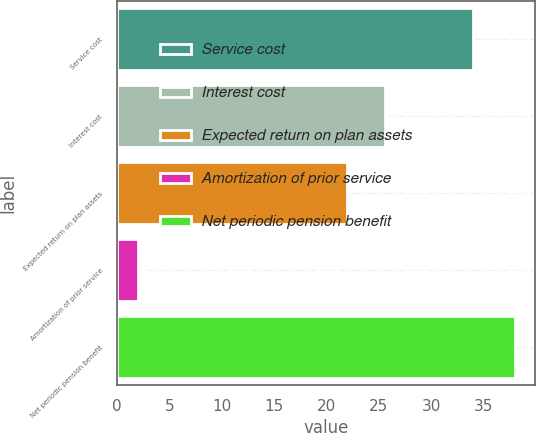<chart> <loc_0><loc_0><loc_500><loc_500><bar_chart><fcel>Service cost<fcel>Interest cost<fcel>Expected return on plan assets<fcel>Amortization of prior service<fcel>Net periodic pension benefit<nl><fcel>34<fcel>25.6<fcel>22<fcel>2<fcel>38<nl></chart> 